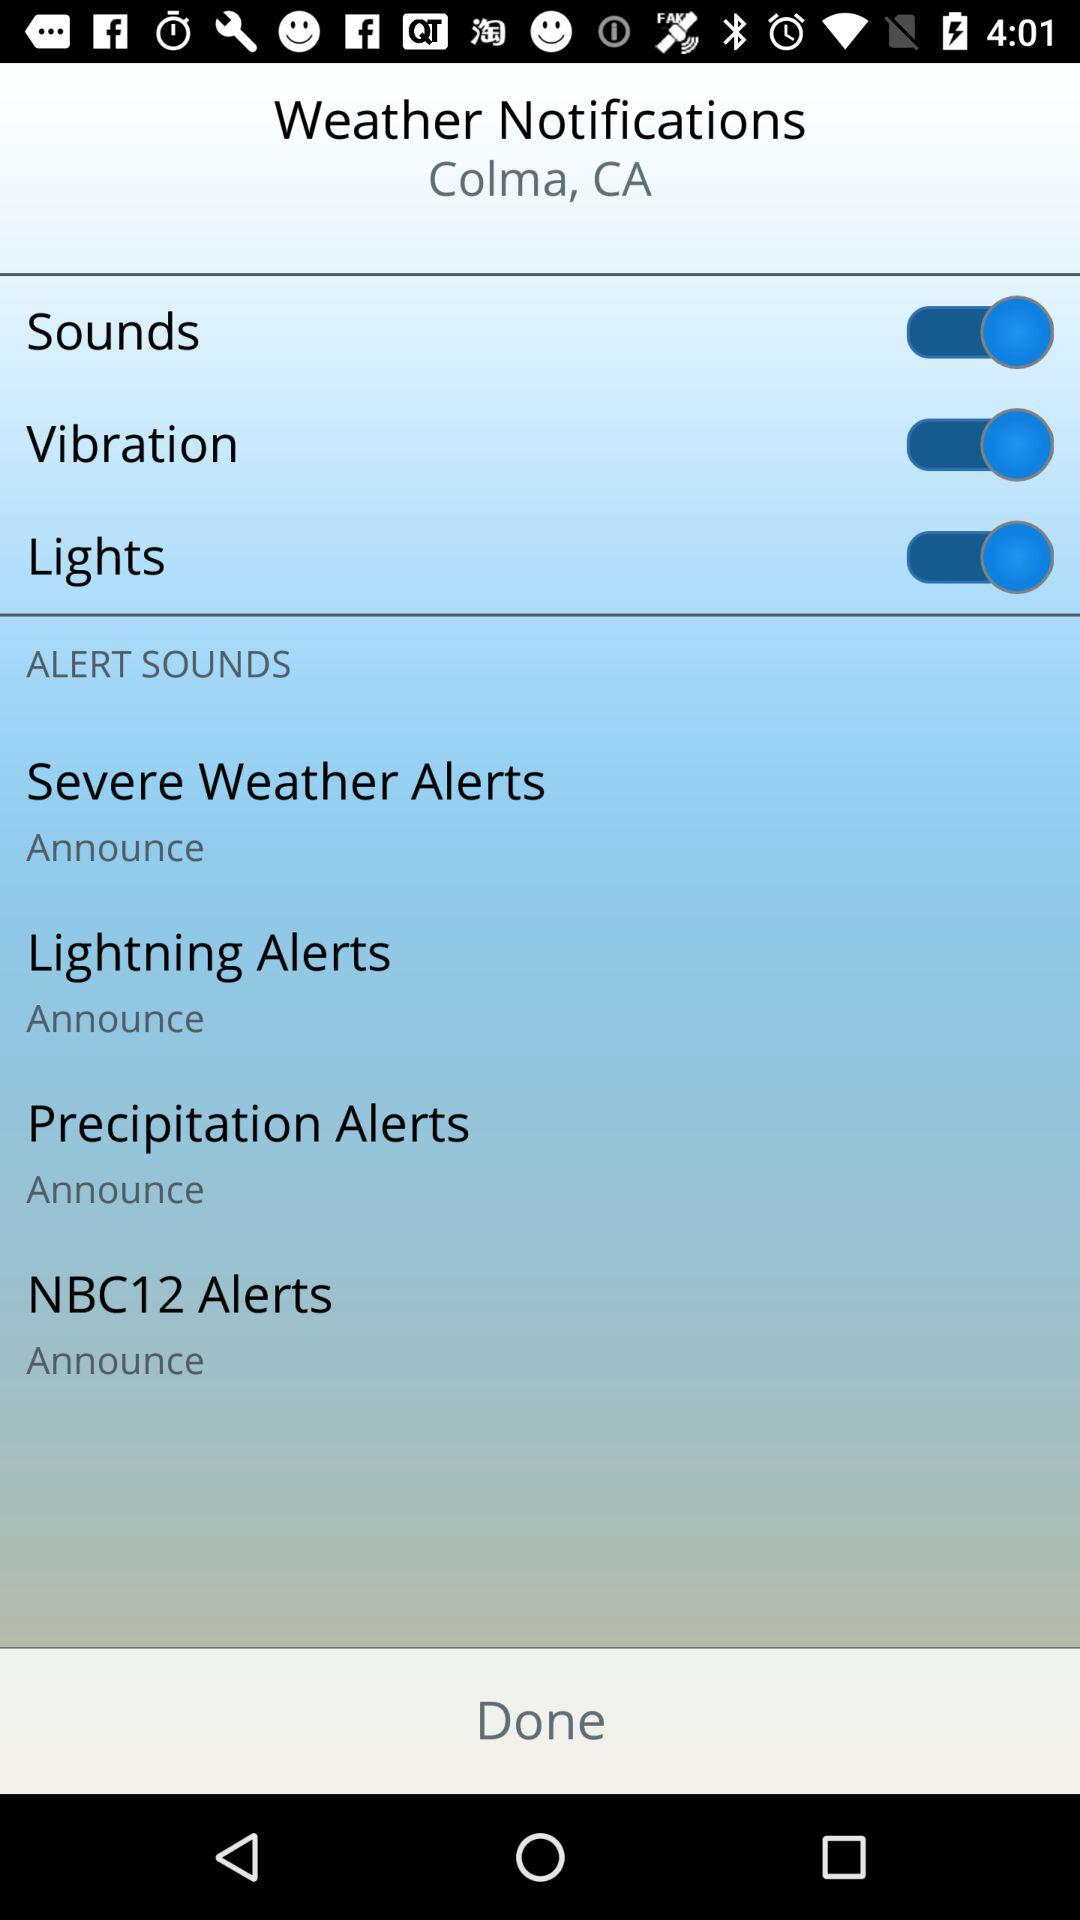What is the location? The location is Colma, CA. 